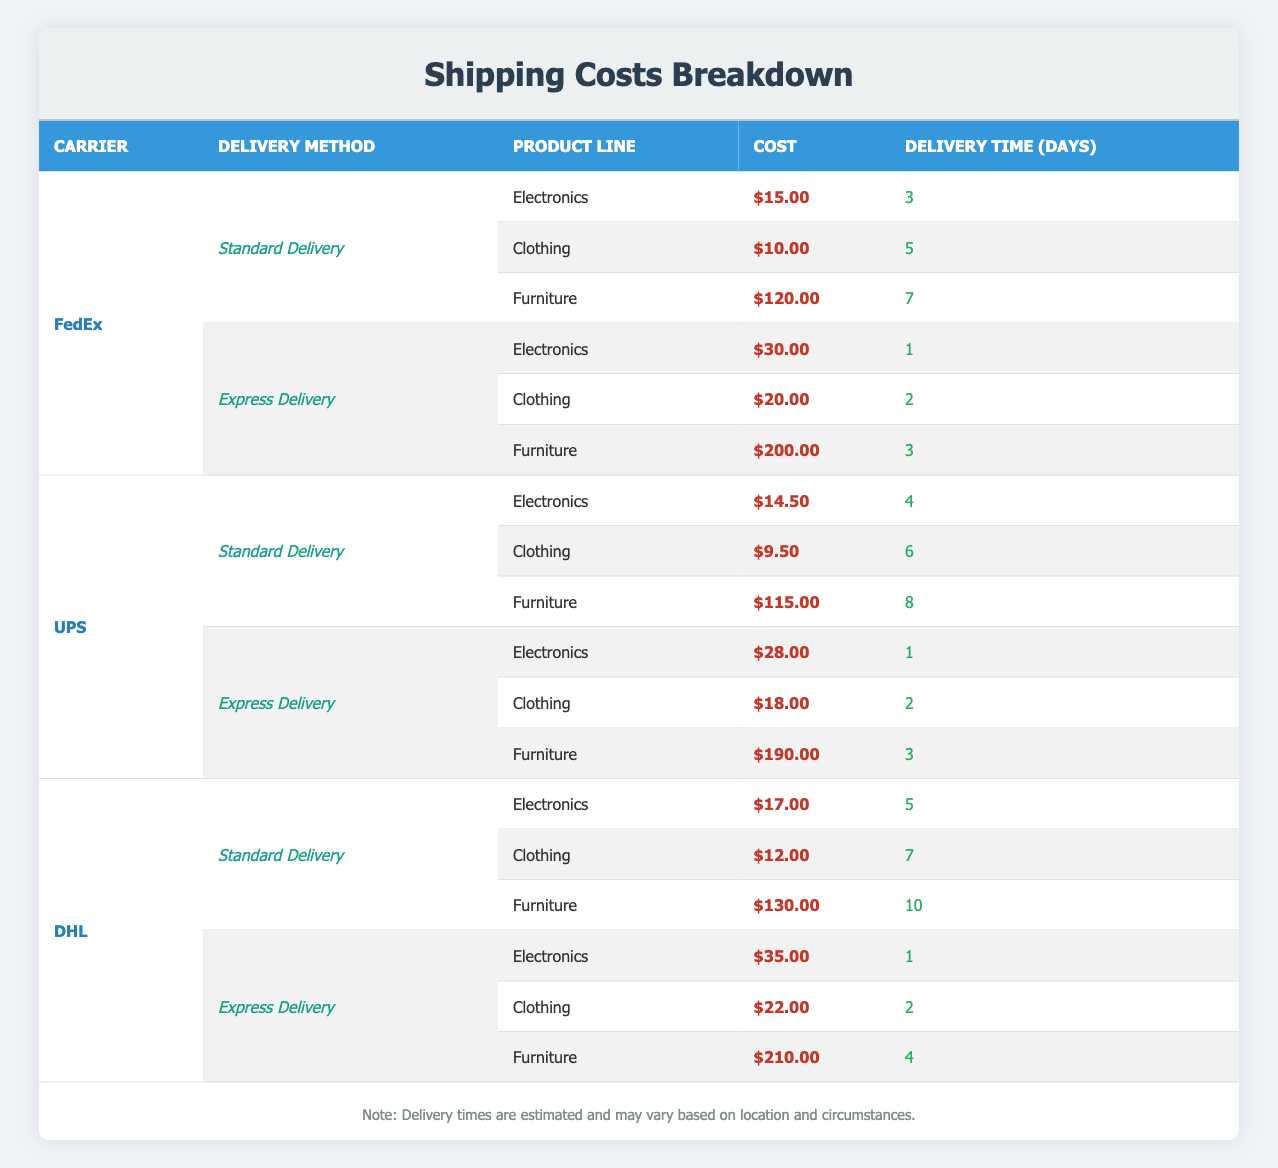What is the cost for standard delivery of electronics via FedEx? Looking at the table, under the FedEx carrier for standard delivery, I see that the cost listed for electronics is $15.00.
Answer: $15.00 What is the delivery time for clothing using UPS express delivery? In the table, under the UPS carrier for express delivery, the delivery time for clothing is specified as 2 days.
Answer: 2 days Which carrier offers the lowest cost for furniture with standard delivery? To find this, I compare the costs of furniture under standard delivery for all carriers: FedEx ($120.00), UPS ($115.00), and DHL ($130.00). The lowest cost is found with UPS at $115.00.
Answer: UPS - $115.00 What is the total shipping cost for sending one unit of electronics and one unit of clothing via DHL express delivery? For DHL express delivery, the cost for electronics is $35.00 and for clothing it is $22.00. Adding these gives a total of $35.00 + $22.00 = $57.00.
Answer: $57.00 Is the delivery time for electronics longer with express delivery than with standard delivery for any carrier? I check each carrier's delivery times for electronics: FedEx express (1 day) vs. standard (3 days), UPS express (1 day) vs. standard (4 days), and DHL express (1 day) vs. standard (5 days). All express delivery options are shorter than standard delivery. Therefore, the statement is false.
Answer: No Which delivery method has the longest delivery time for clothing and what is that time? I look for the delivery times for clothing across all carriers and methods: FedEx standard (5 days), UPS standard (6 days), DHL standard (7 days), FedEx express (2 days), UPS express (2 days), and DHL express (2 days). The longest identified is DHL standard delivery at 7 days.
Answer: DHL standard delivery - 7 days What is the average cost of shipping furniture using all carriers with express delivery? I first find the costs for furniture express delivery: FedEx ($200.00), UPS ($190.00), and DHL ($210.00). Adding these gives $200.00 + $190.00 + $210.00 = $600.00. Then, dividing by 3 provides the average cost: $600.00 / 3 = $200.00.
Answer: $200.00 Does the shipping cost for clothing using FedEx express delivery exceed $20.00? According to the table, the cost for clothing with FedEx express delivery is $20.00, which does not exceed $20.00 hence the answer is false.
Answer: No Which carrier has a faster delivery time for furniture compared to FedEx's standard delivery? FedEx's standard delivery time for furniture is 7 days. I check UPS standard (8 days) and DHL standard (10 days). Both of these options are longer than FedEx's 7 days, confirming no carrier is faster. FedEx is the quickest.
Answer: None 